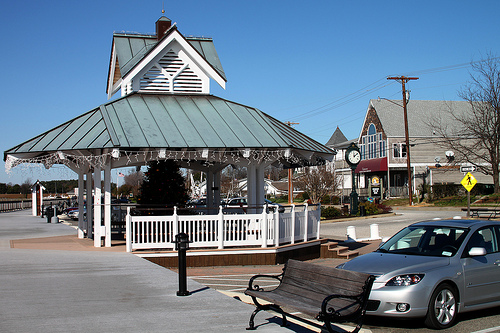Please provide a short description for this region: [0.52, 0.67, 0.75, 0.83]. The region defined by coordinates [0.52, 0.67, 0.75, 0.83] appears to contain a wooden bench situated on a boardwalk. 